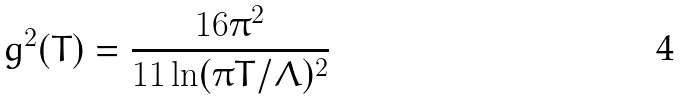<formula> <loc_0><loc_0><loc_500><loc_500>g ^ { 2 } ( T ) = \frac { 1 6 \pi ^ { 2 } } { 1 1 \ln ( \pi T / \Lambda ) ^ { 2 } }</formula> 